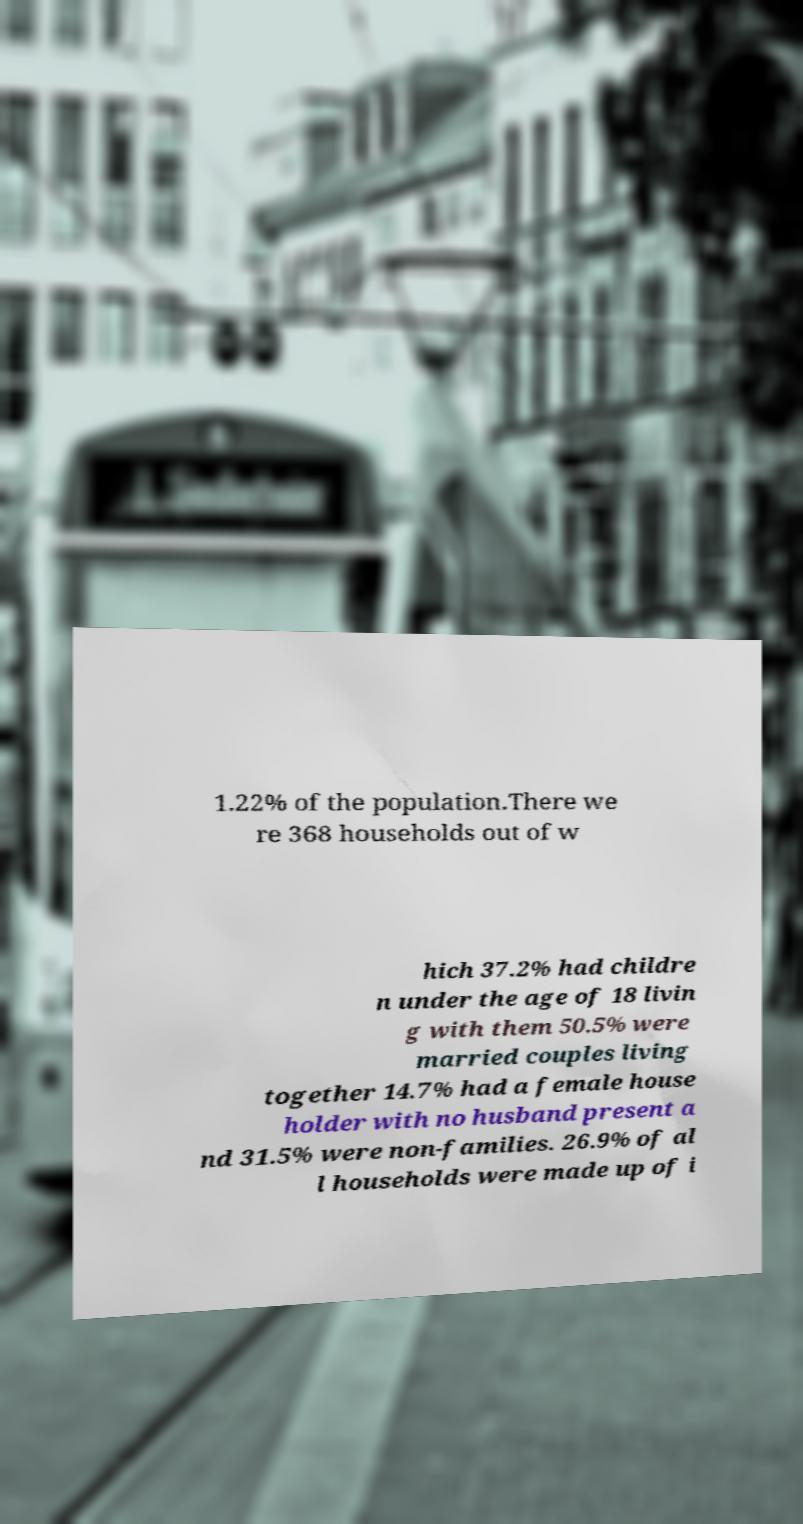Could you extract and type out the text from this image? 1.22% of the population.There we re 368 households out of w hich 37.2% had childre n under the age of 18 livin g with them 50.5% were married couples living together 14.7% had a female house holder with no husband present a nd 31.5% were non-families. 26.9% of al l households were made up of i 